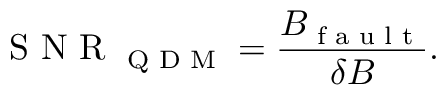<formula> <loc_0><loc_0><loc_500><loc_500>S N R _ { Q D M } = \frac { B _ { f a u l t } } { \delta B } .</formula> 